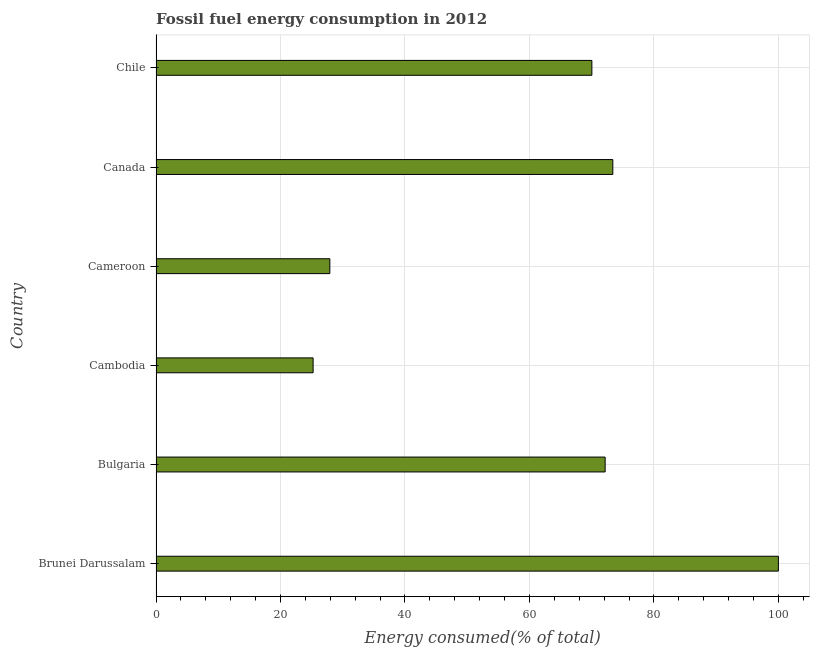Does the graph contain any zero values?
Offer a terse response. No. Does the graph contain grids?
Your response must be concise. Yes. What is the title of the graph?
Provide a short and direct response. Fossil fuel energy consumption in 2012. What is the label or title of the X-axis?
Your answer should be compact. Energy consumed(% of total). What is the label or title of the Y-axis?
Your response must be concise. Country. What is the fossil fuel energy consumption in Brunei Darussalam?
Your answer should be compact. 100. Across all countries, what is the maximum fossil fuel energy consumption?
Ensure brevity in your answer.  100. Across all countries, what is the minimum fossil fuel energy consumption?
Provide a succinct answer. 25.24. In which country was the fossil fuel energy consumption maximum?
Offer a very short reply. Brunei Darussalam. In which country was the fossil fuel energy consumption minimum?
Provide a succinct answer. Cambodia. What is the sum of the fossil fuel energy consumption?
Provide a short and direct response. 368.75. What is the difference between the fossil fuel energy consumption in Brunei Darussalam and Cameroon?
Provide a short and direct response. 72.07. What is the average fossil fuel energy consumption per country?
Your answer should be compact. 61.46. What is the median fossil fuel energy consumption?
Your response must be concise. 71.1. What is the ratio of the fossil fuel energy consumption in Brunei Darussalam to that in Canada?
Give a very brief answer. 1.36. Is the difference between the fossil fuel energy consumption in Canada and Chile greater than the difference between any two countries?
Provide a short and direct response. No. What is the difference between the highest and the second highest fossil fuel energy consumption?
Your response must be concise. 26.6. What is the difference between the highest and the lowest fossil fuel energy consumption?
Keep it short and to the point. 74.76. How many bars are there?
Your answer should be compact. 6. How many countries are there in the graph?
Give a very brief answer. 6. What is the difference between two consecutive major ticks on the X-axis?
Give a very brief answer. 20. Are the values on the major ticks of X-axis written in scientific E-notation?
Your response must be concise. No. What is the Energy consumed(% of total) in Brunei Darussalam?
Offer a terse response. 100. What is the Energy consumed(% of total) in Bulgaria?
Keep it short and to the point. 72.16. What is the Energy consumed(% of total) of Cambodia?
Your answer should be very brief. 25.24. What is the Energy consumed(% of total) of Cameroon?
Offer a terse response. 27.93. What is the Energy consumed(% of total) of Canada?
Your response must be concise. 73.4. What is the Energy consumed(% of total) of Chile?
Give a very brief answer. 70.03. What is the difference between the Energy consumed(% of total) in Brunei Darussalam and Bulgaria?
Your answer should be very brief. 27.83. What is the difference between the Energy consumed(% of total) in Brunei Darussalam and Cambodia?
Your answer should be very brief. 74.76. What is the difference between the Energy consumed(% of total) in Brunei Darussalam and Cameroon?
Your answer should be compact. 72.07. What is the difference between the Energy consumed(% of total) in Brunei Darussalam and Canada?
Make the answer very short. 26.6. What is the difference between the Energy consumed(% of total) in Brunei Darussalam and Chile?
Offer a terse response. 29.97. What is the difference between the Energy consumed(% of total) in Bulgaria and Cambodia?
Your answer should be compact. 46.92. What is the difference between the Energy consumed(% of total) in Bulgaria and Cameroon?
Provide a succinct answer. 44.23. What is the difference between the Energy consumed(% of total) in Bulgaria and Canada?
Make the answer very short. -1.23. What is the difference between the Energy consumed(% of total) in Bulgaria and Chile?
Keep it short and to the point. 2.13. What is the difference between the Energy consumed(% of total) in Cambodia and Cameroon?
Offer a very short reply. -2.69. What is the difference between the Energy consumed(% of total) in Cambodia and Canada?
Offer a very short reply. -48.16. What is the difference between the Energy consumed(% of total) in Cambodia and Chile?
Make the answer very short. -44.79. What is the difference between the Energy consumed(% of total) in Cameroon and Canada?
Provide a short and direct response. -45.47. What is the difference between the Energy consumed(% of total) in Cameroon and Chile?
Offer a very short reply. -42.1. What is the difference between the Energy consumed(% of total) in Canada and Chile?
Offer a very short reply. 3.37. What is the ratio of the Energy consumed(% of total) in Brunei Darussalam to that in Bulgaria?
Offer a very short reply. 1.39. What is the ratio of the Energy consumed(% of total) in Brunei Darussalam to that in Cambodia?
Make the answer very short. 3.96. What is the ratio of the Energy consumed(% of total) in Brunei Darussalam to that in Cameroon?
Provide a short and direct response. 3.58. What is the ratio of the Energy consumed(% of total) in Brunei Darussalam to that in Canada?
Give a very brief answer. 1.36. What is the ratio of the Energy consumed(% of total) in Brunei Darussalam to that in Chile?
Your answer should be very brief. 1.43. What is the ratio of the Energy consumed(% of total) in Bulgaria to that in Cambodia?
Give a very brief answer. 2.86. What is the ratio of the Energy consumed(% of total) in Bulgaria to that in Cameroon?
Give a very brief answer. 2.58. What is the ratio of the Energy consumed(% of total) in Cambodia to that in Cameroon?
Give a very brief answer. 0.9. What is the ratio of the Energy consumed(% of total) in Cambodia to that in Canada?
Make the answer very short. 0.34. What is the ratio of the Energy consumed(% of total) in Cambodia to that in Chile?
Your response must be concise. 0.36. What is the ratio of the Energy consumed(% of total) in Cameroon to that in Canada?
Your answer should be very brief. 0.38. What is the ratio of the Energy consumed(% of total) in Cameroon to that in Chile?
Give a very brief answer. 0.4. What is the ratio of the Energy consumed(% of total) in Canada to that in Chile?
Give a very brief answer. 1.05. 